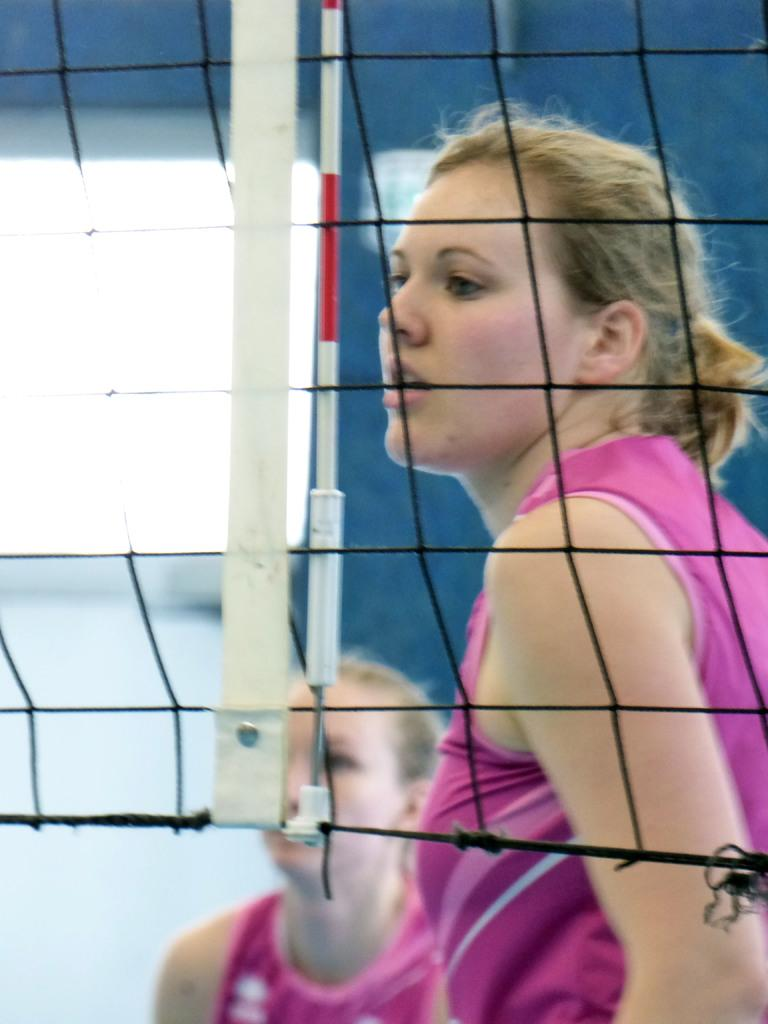What type of sports equipment is present in the image? There is a sports net in the image. How many people are visible in the image? There are two women standing in the image. Can you describe the background of the image? The background of the image is blurred. What type of table is visible in the image? There is no table present in the image. Can you describe the office setting in the image? There is no office setting present in the image. 